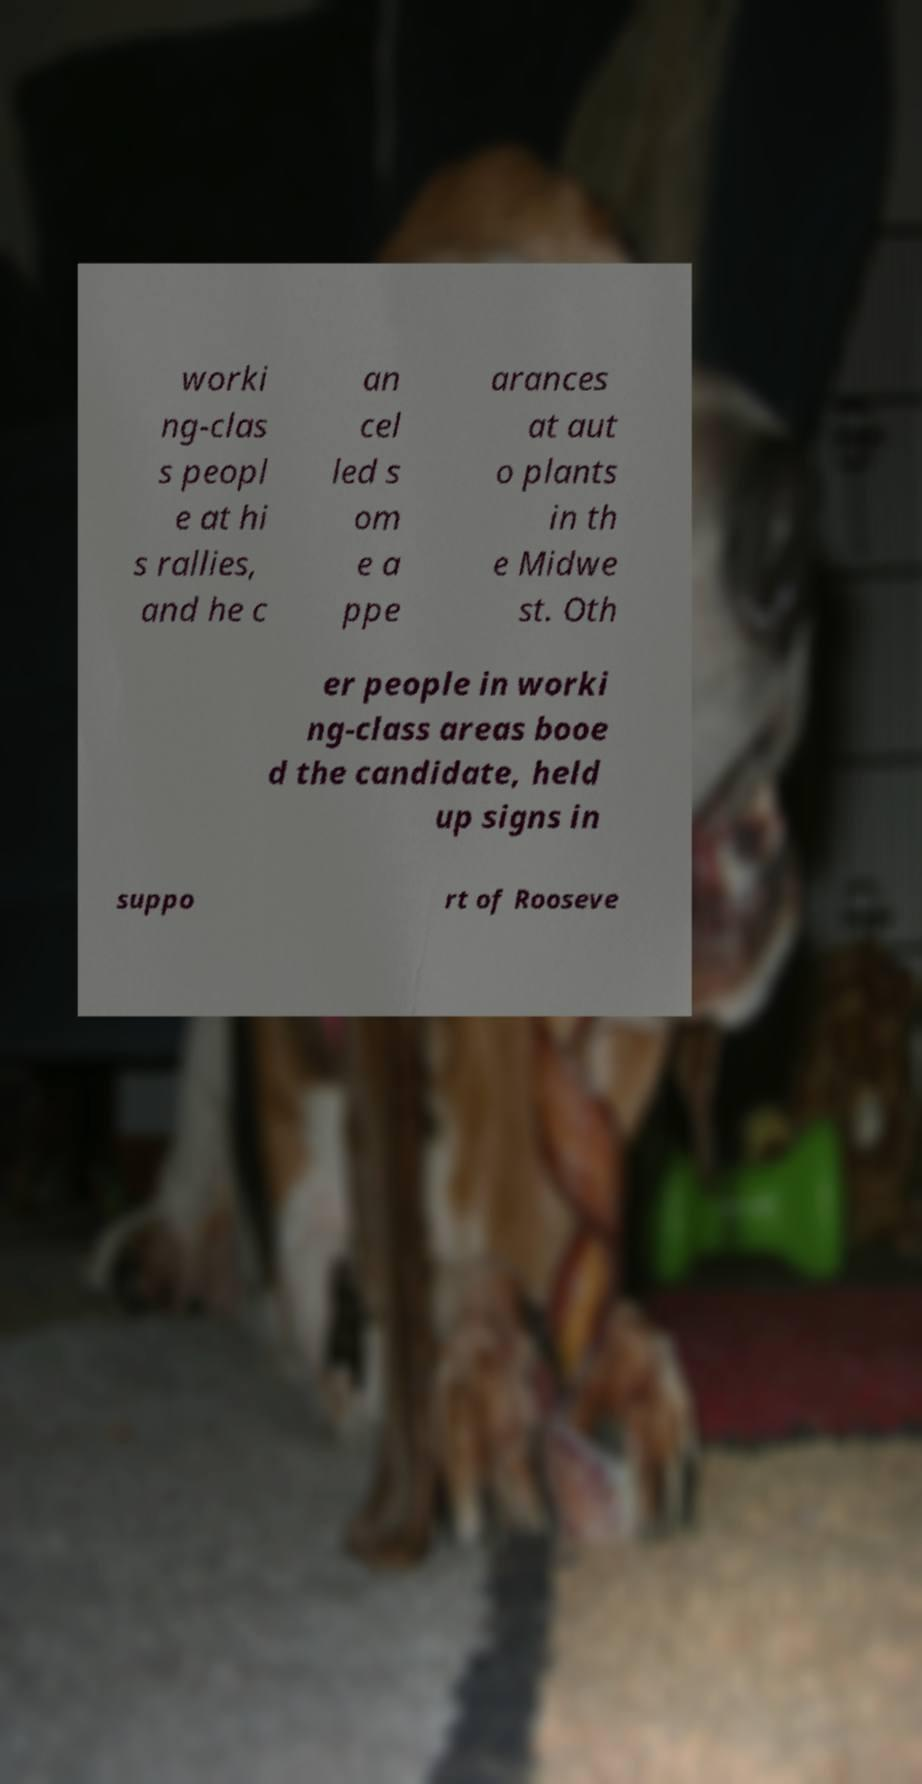Please read and relay the text visible in this image. What does it say? worki ng-clas s peopl e at hi s rallies, and he c an cel led s om e a ppe arances at aut o plants in th e Midwe st. Oth er people in worki ng-class areas booe d the candidate, held up signs in suppo rt of Rooseve 